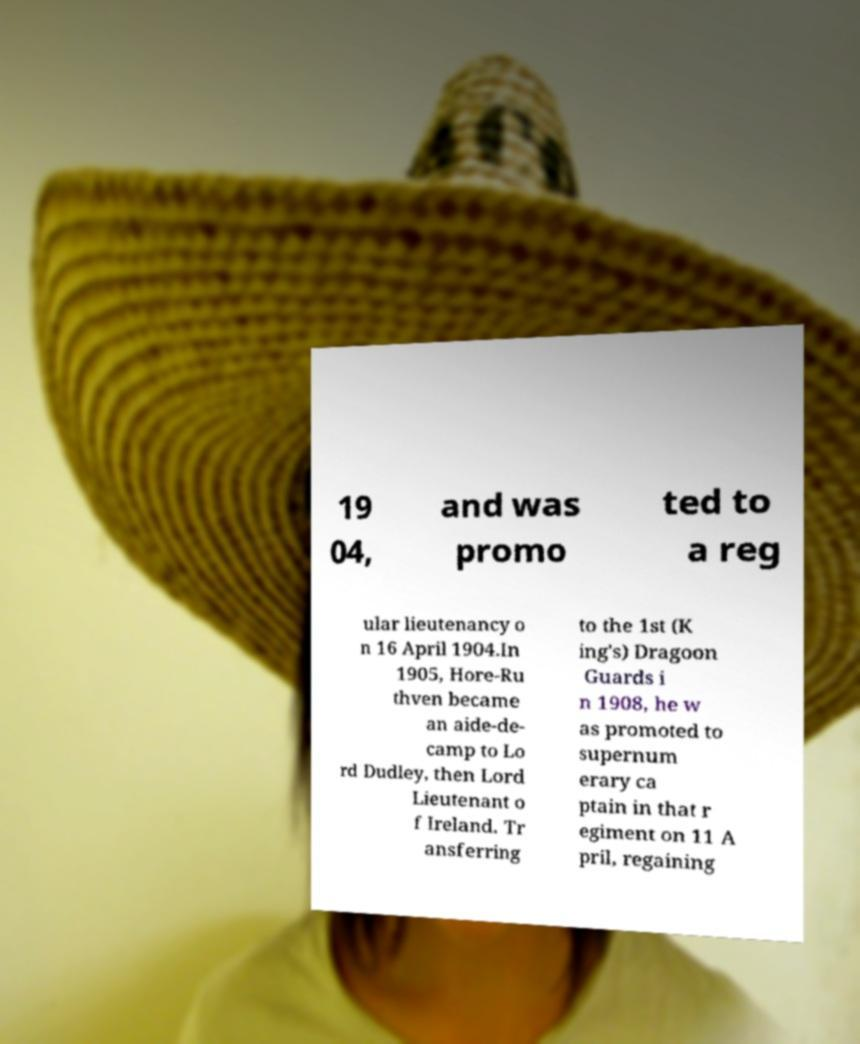Please identify and transcribe the text found in this image. 19 04, and was promo ted to a reg ular lieutenancy o n 16 April 1904.In 1905, Hore-Ru thven became an aide-de- camp to Lo rd Dudley, then Lord Lieutenant o f Ireland. Tr ansferring to the 1st (K ing's) Dragoon Guards i n 1908, he w as promoted to supernum erary ca ptain in that r egiment on 11 A pril, regaining 